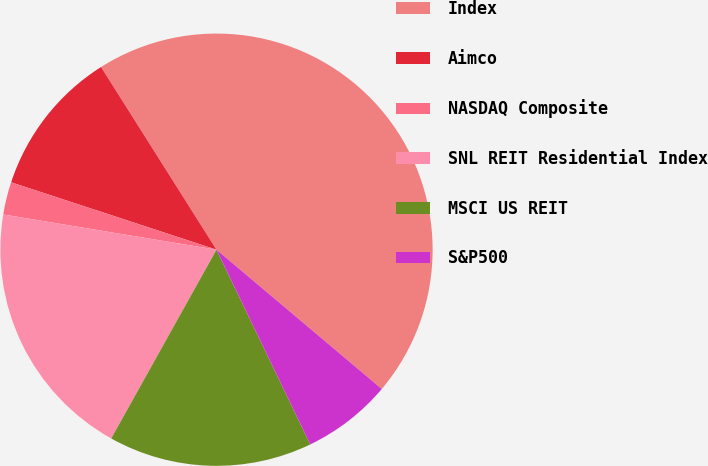<chart> <loc_0><loc_0><loc_500><loc_500><pie_chart><fcel>Index<fcel>Aimco<fcel>NASDAQ Composite<fcel>SNL REIT Residential Index<fcel>MSCI US REIT<fcel>S&P500<nl><fcel>45.11%<fcel>10.98%<fcel>2.44%<fcel>19.51%<fcel>15.24%<fcel>6.71%<nl></chart> 